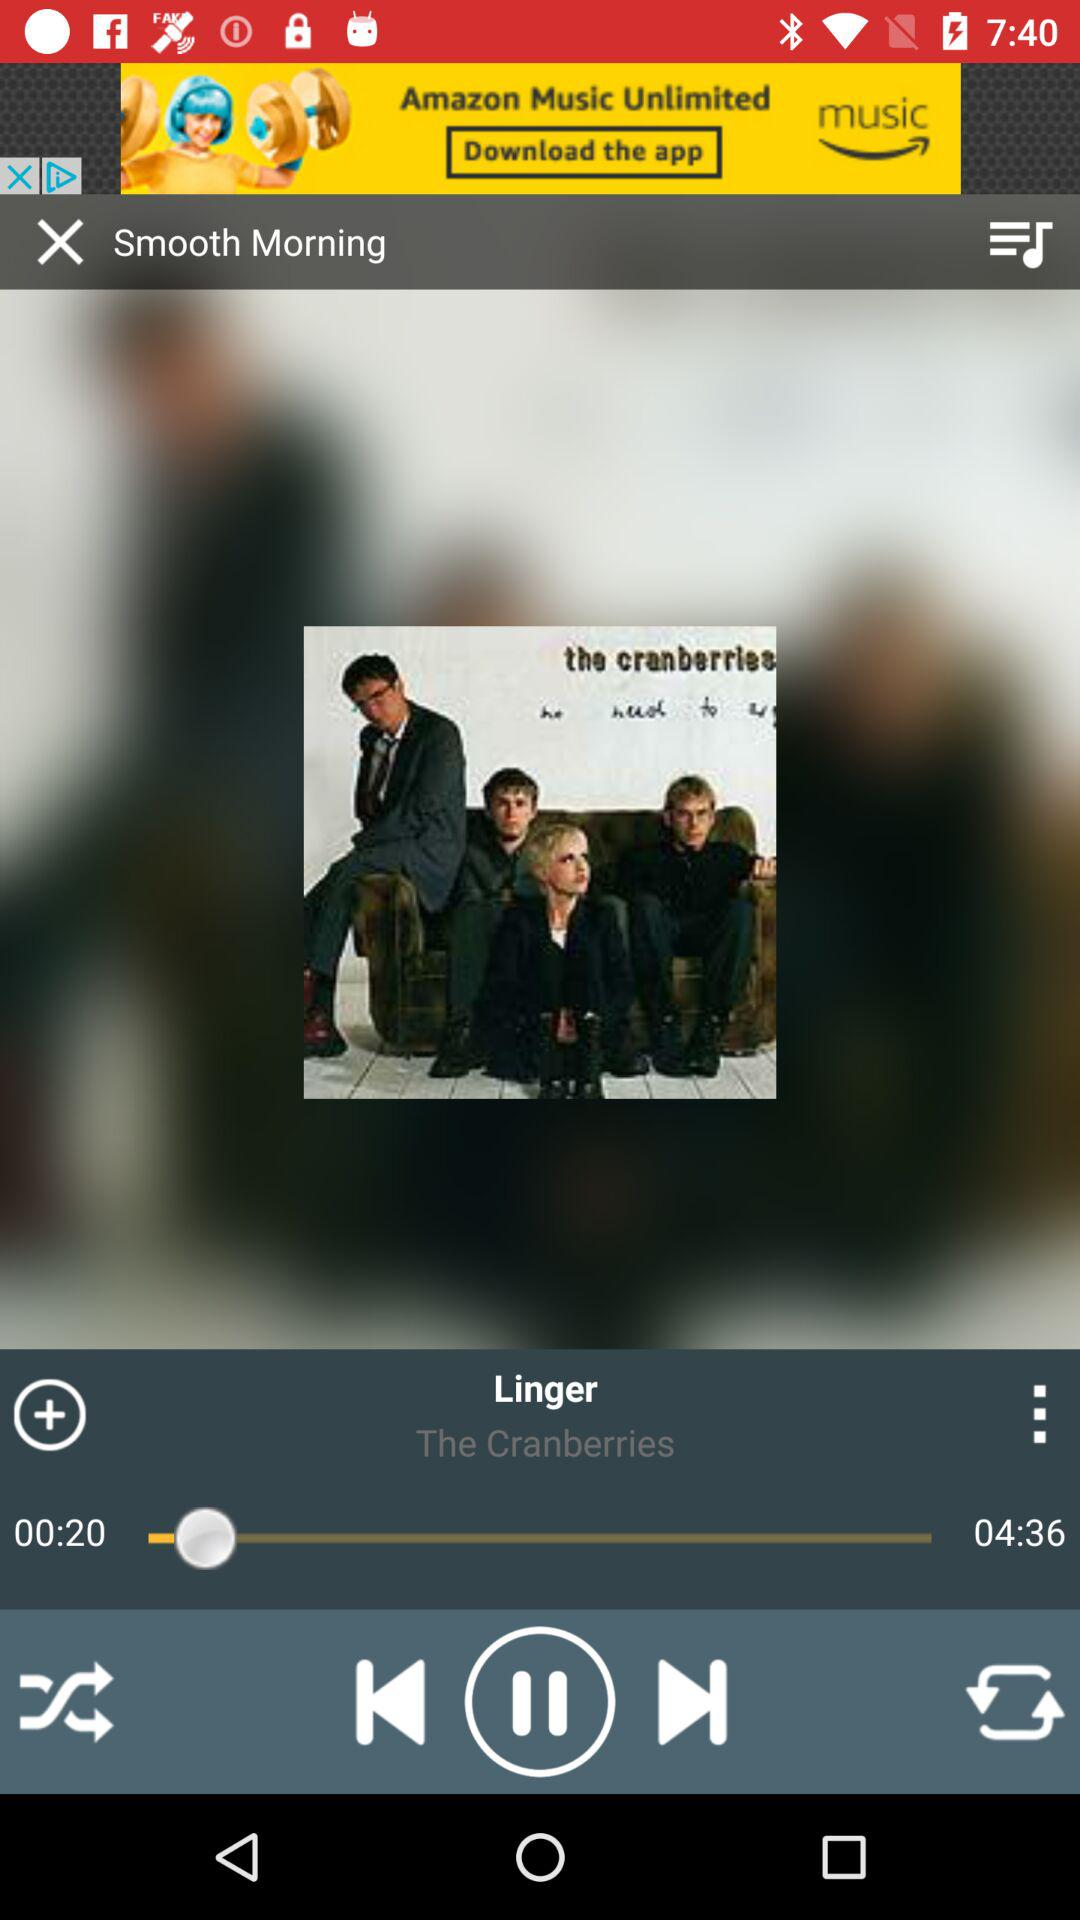What song is playing? The song "Linger" is playing. 